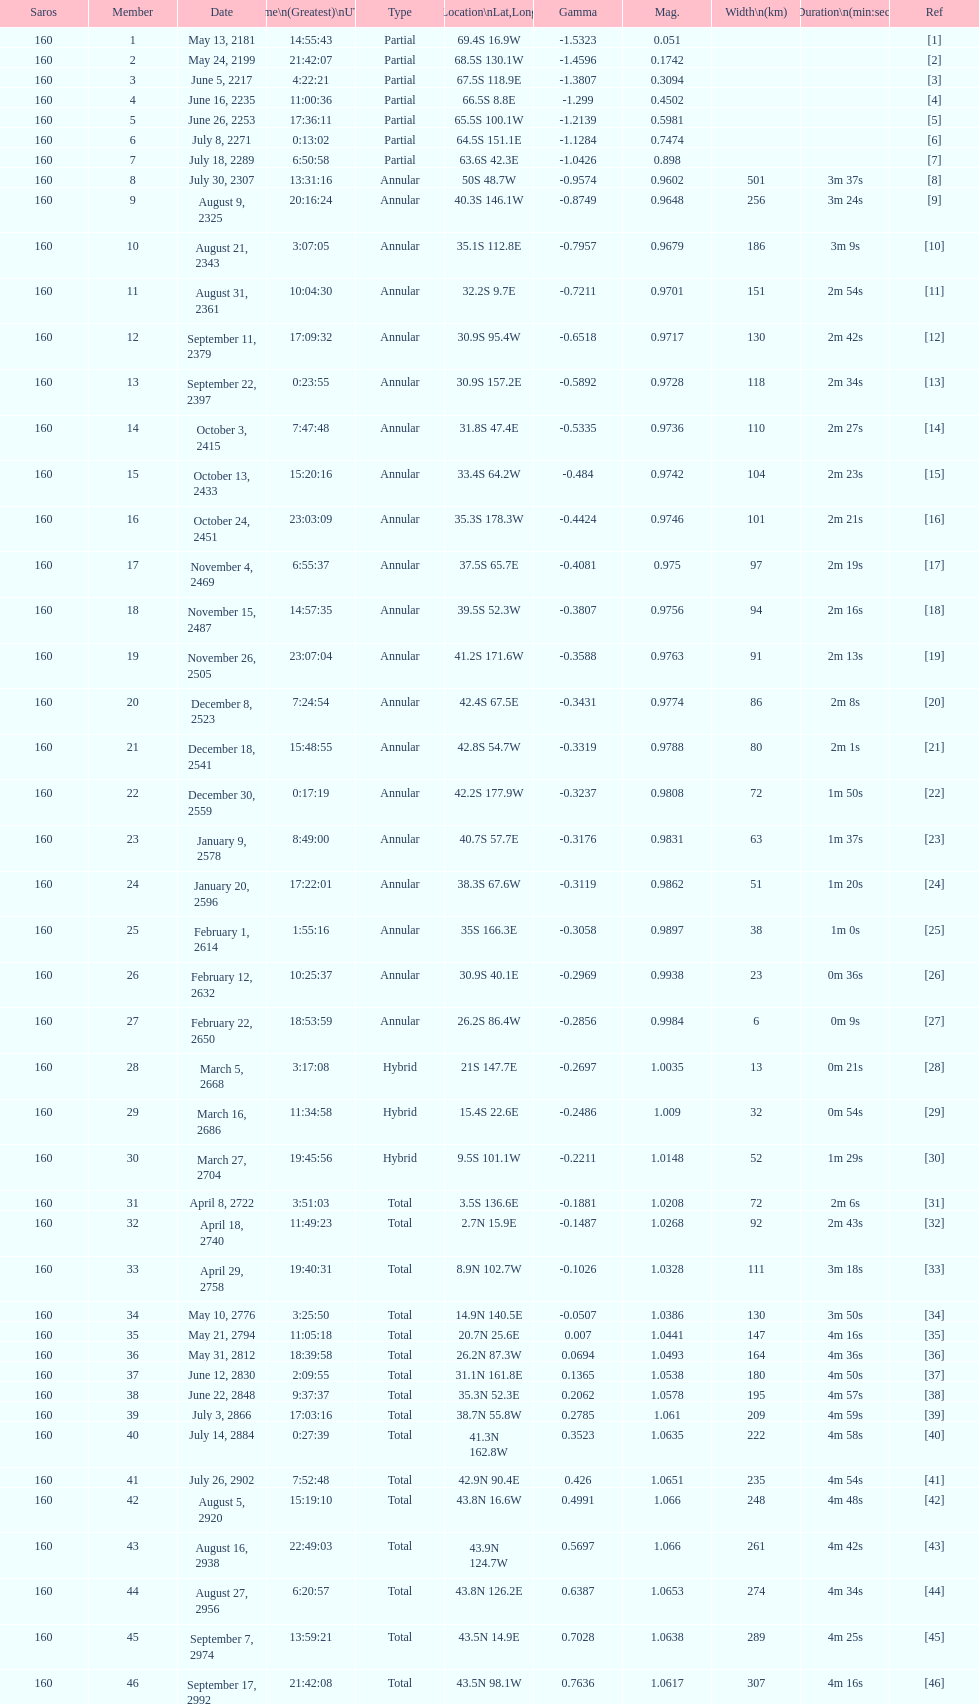When did the premier solar saros with a magnitude of more than March 5, 2668. 